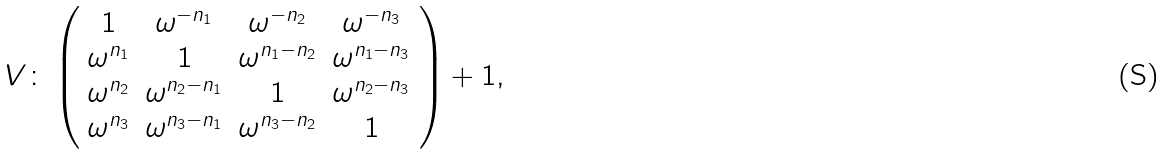Convert formula to latex. <formula><loc_0><loc_0><loc_500><loc_500>V \colon \left ( \begin{array} { c c c c } 1 & \omega ^ { - n _ { 1 } } & \omega ^ { - n _ { 2 } } & \omega ^ { - n _ { 3 } } \\ \omega ^ { n _ { 1 } } & 1 & \omega ^ { n _ { 1 } - n _ { 2 } } & \omega ^ { n _ { 1 } - n _ { 3 } } \\ \omega ^ { n _ { 2 } } & \omega ^ { n _ { 2 } - n _ { 1 } } & 1 & \omega ^ { n _ { 2 } - n _ { 3 } } \\ \omega ^ { n _ { 3 } } & \omega ^ { n _ { 3 } - n _ { 1 } } & \omega ^ { n _ { 3 } - n _ { 2 } } & 1 \end{array} \right ) + 1 , \,</formula> 